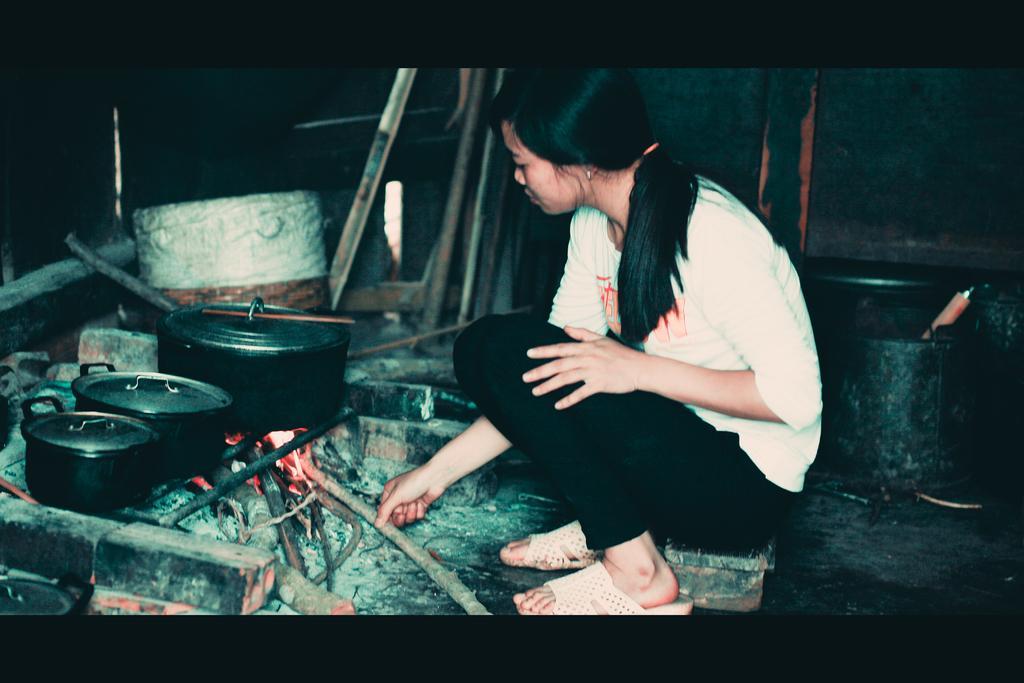Can you describe this image briefly? In this picture we can see a woman sitting and she is holding a wooden stick with her hand. We can see fire and cooking containers. 